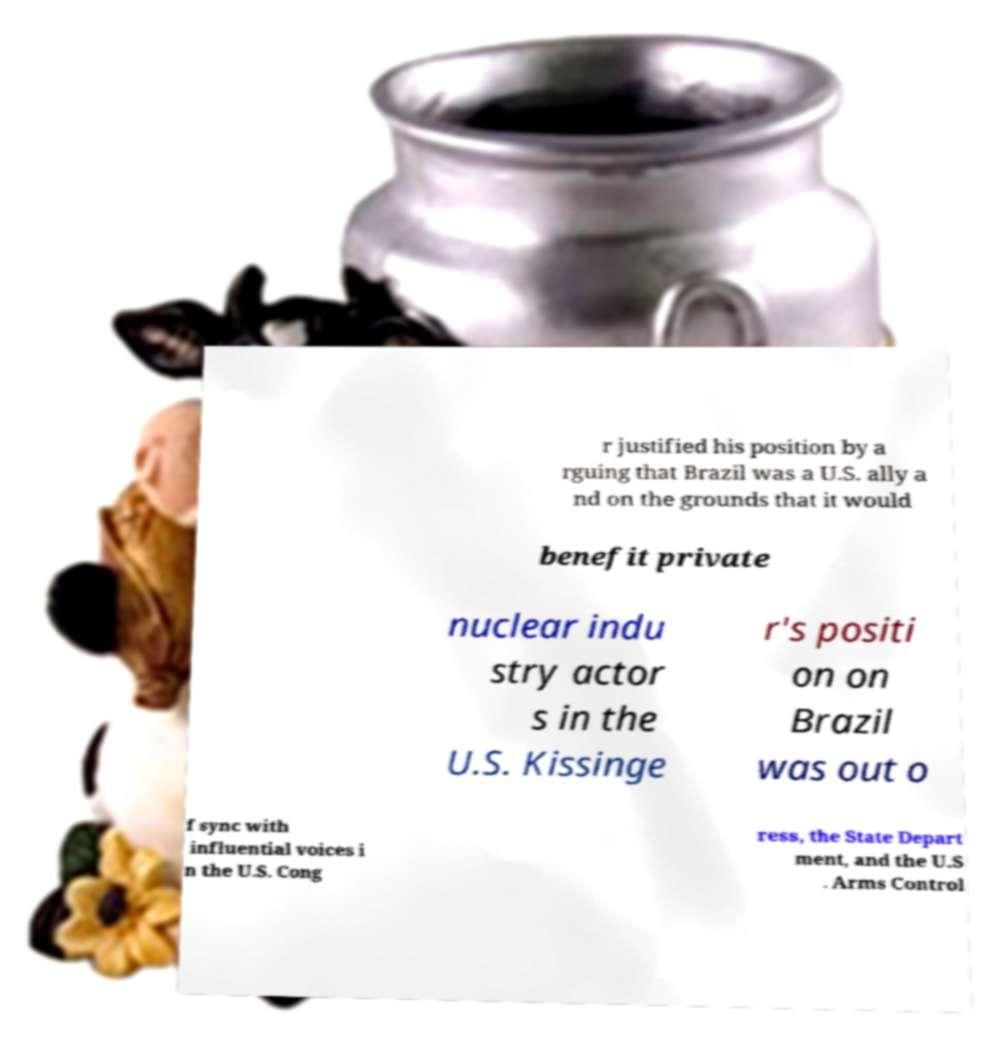Could you extract and type out the text from this image? r justified his position by a rguing that Brazil was a U.S. ally a nd on the grounds that it would benefit private nuclear indu stry actor s in the U.S. Kissinge r's positi on on Brazil was out o f sync with influential voices i n the U.S. Cong ress, the State Depart ment, and the U.S . Arms Control 